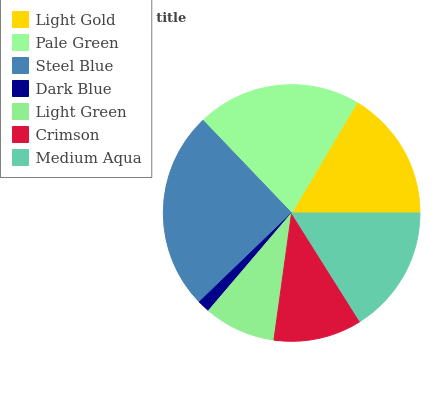Is Dark Blue the minimum?
Answer yes or no. Yes. Is Steel Blue the maximum?
Answer yes or no. Yes. Is Pale Green the minimum?
Answer yes or no. No. Is Pale Green the maximum?
Answer yes or no. No. Is Pale Green greater than Light Gold?
Answer yes or no. Yes. Is Light Gold less than Pale Green?
Answer yes or no. Yes. Is Light Gold greater than Pale Green?
Answer yes or no. No. Is Pale Green less than Light Gold?
Answer yes or no. No. Is Medium Aqua the high median?
Answer yes or no. Yes. Is Medium Aqua the low median?
Answer yes or no. Yes. Is Pale Green the high median?
Answer yes or no. No. Is Crimson the low median?
Answer yes or no. No. 